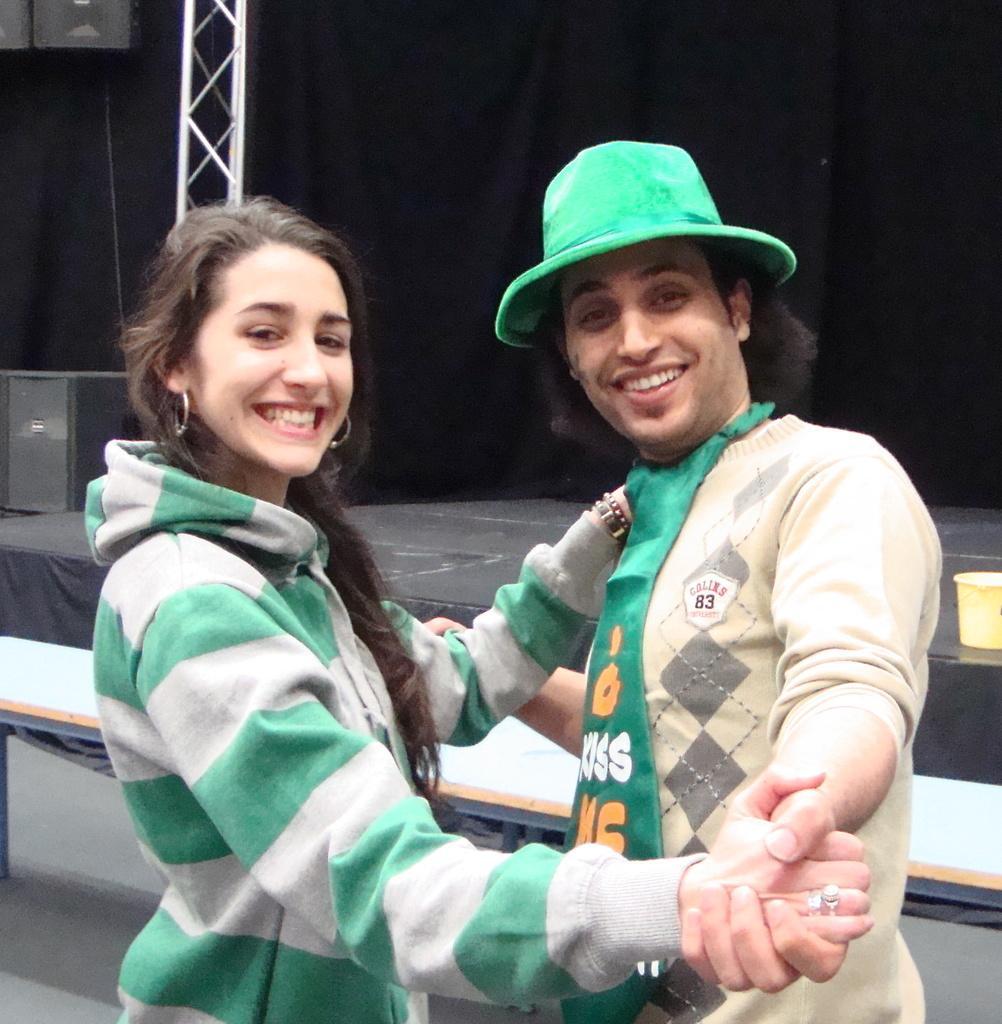Could you give a brief overview of what you see in this image? In the center of the image we can see two people are standing and holding their hands each other and smiling and a man is wearing a hat. In the background of the image we can see the stage, rods, speakers, bucket. 